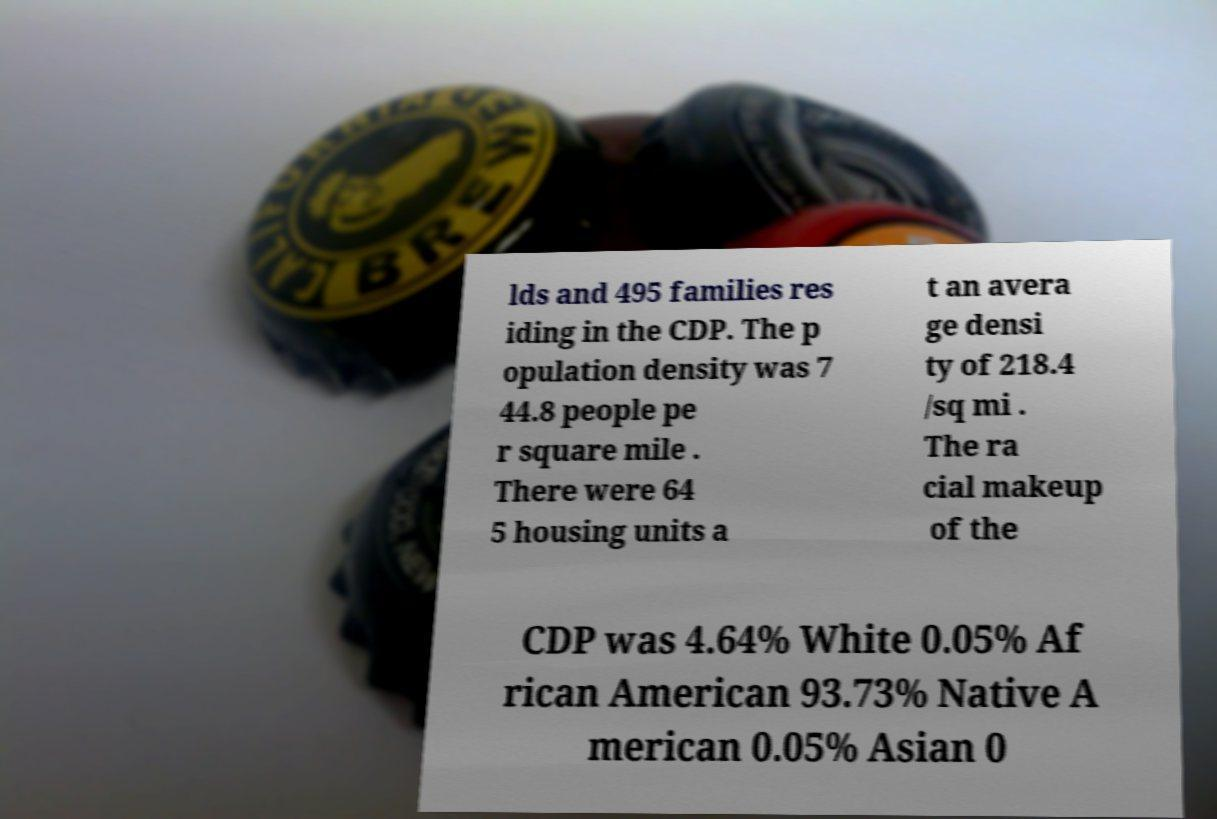Could you assist in decoding the text presented in this image and type it out clearly? lds and 495 families res iding in the CDP. The p opulation density was 7 44.8 people pe r square mile . There were 64 5 housing units a t an avera ge densi ty of 218.4 /sq mi . The ra cial makeup of the CDP was 4.64% White 0.05% Af rican American 93.73% Native A merican 0.05% Asian 0 